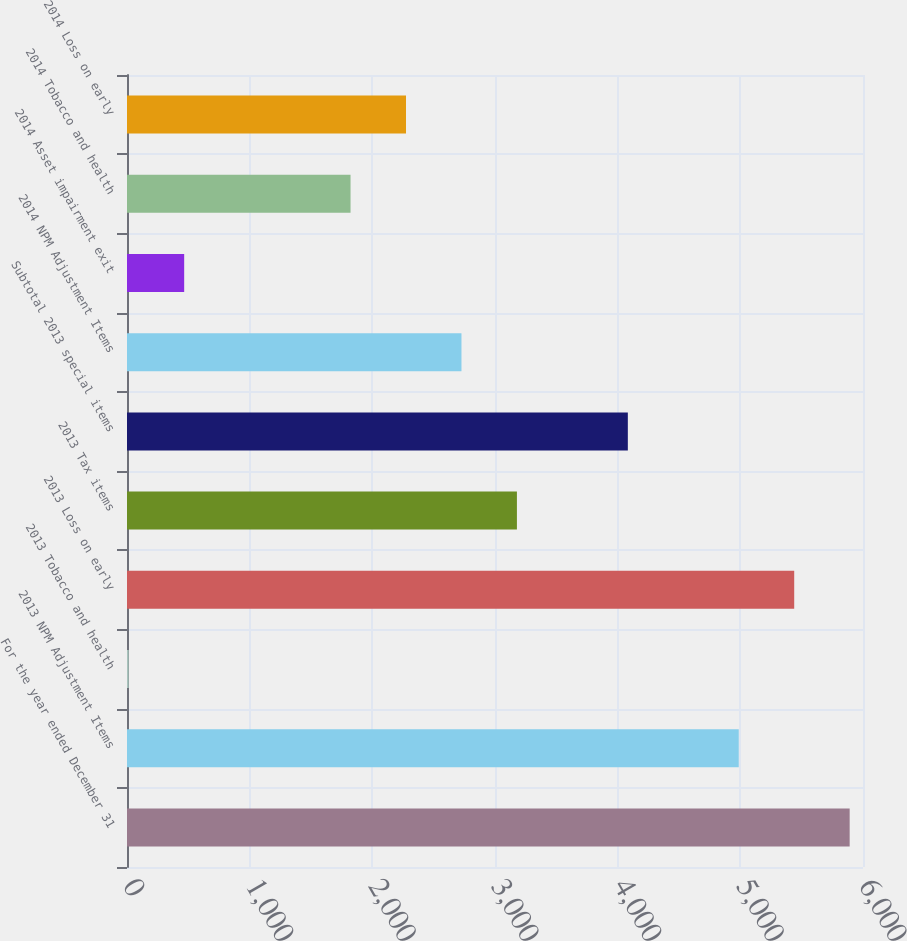Convert chart to OTSL. <chart><loc_0><loc_0><loc_500><loc_500><bar_chart><fcel>For the year ended December 31<fcel>2013 NPM Adjustment Items<fcel>2013 Tobacco and health<fcel>2013 Loss on early<fcel>2013 Tax items<fcel>Subtotal 2013 special items<fcel>2014 NPM Adjustment Items<fcel>2014 Asset impairment exit<fcel>2014 Tobacco and health<fcel>2014 Loss on early<nl><fcel>5891.3<fcel>4987.1<fcel>14<fcel>5439.2<fcel>3178.7<fcel>4082.9<fcel>2726.6<fcel>466.1<fcel>1822.4<fcel>2274.5<nl></chart> 